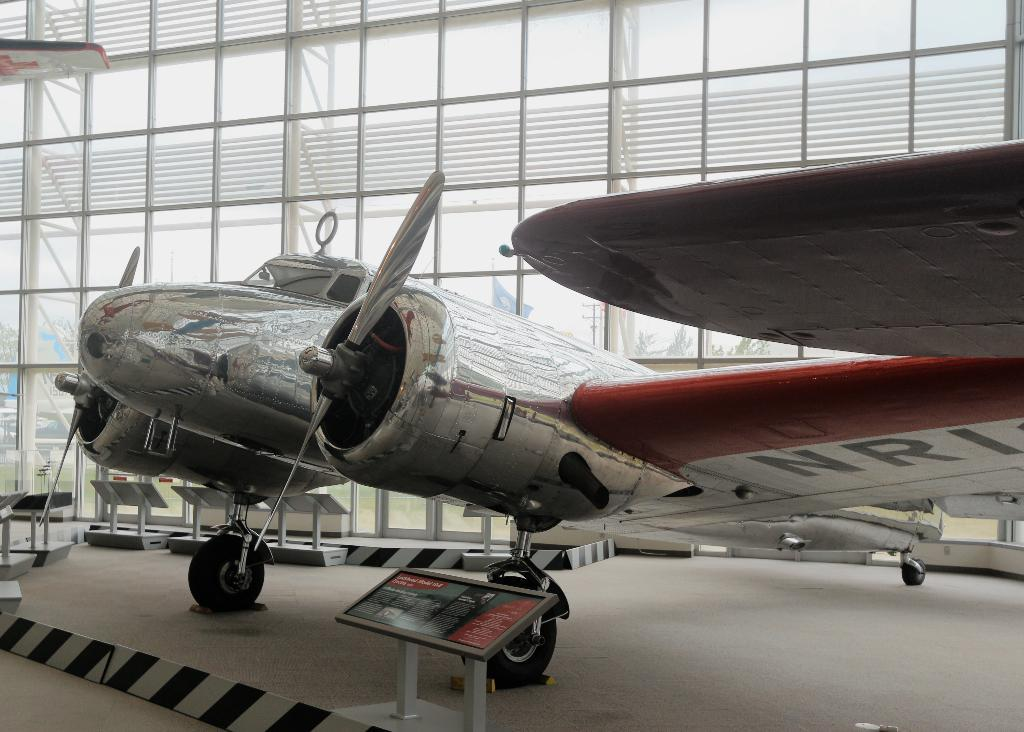<image>
Share a concise interpretation of the image provided. An airplane has the letters "NRI" on the wing. 